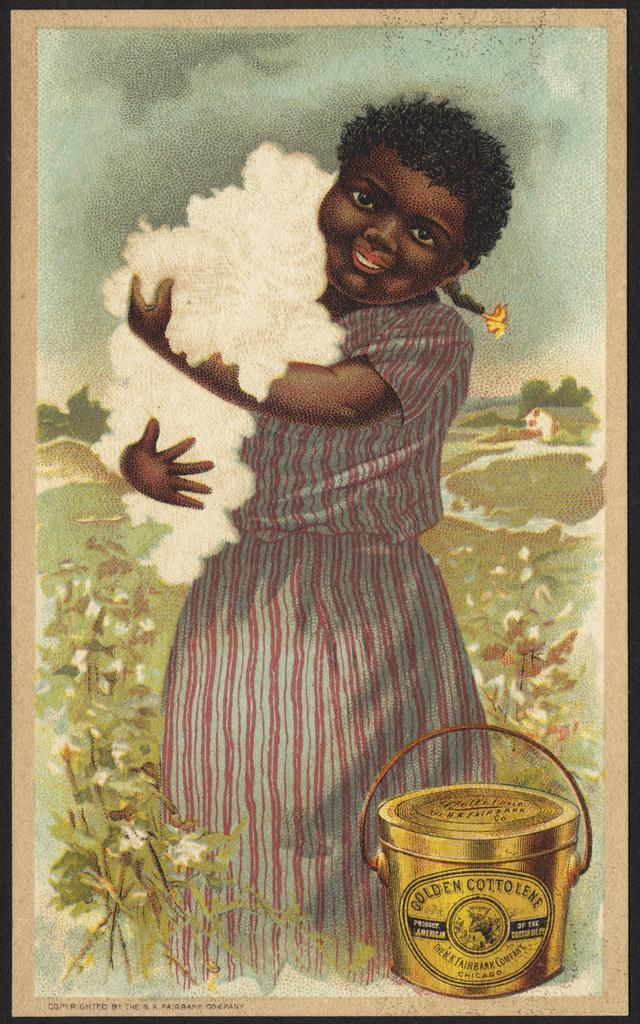Provide a one-sentence caption for the provided image. An old advertisement for Golden Cottolene features a young girl holding cotton. 